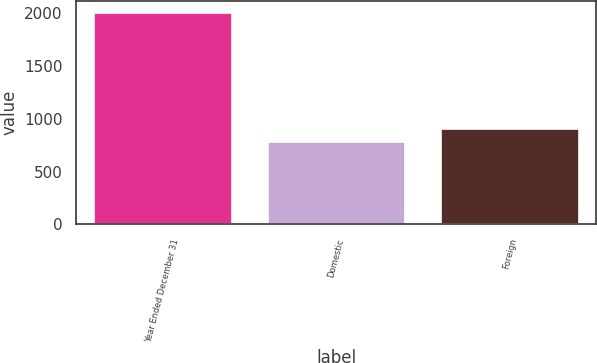<chart> <loc_0><loc_0><loc_500><loc_500><bar_chart><fcel>Year Ended December 31<fcel>Domestic<fcel>Foreign<nl><fcel>2012<fcel>786.6<fcel>909.14<nl></chart> 